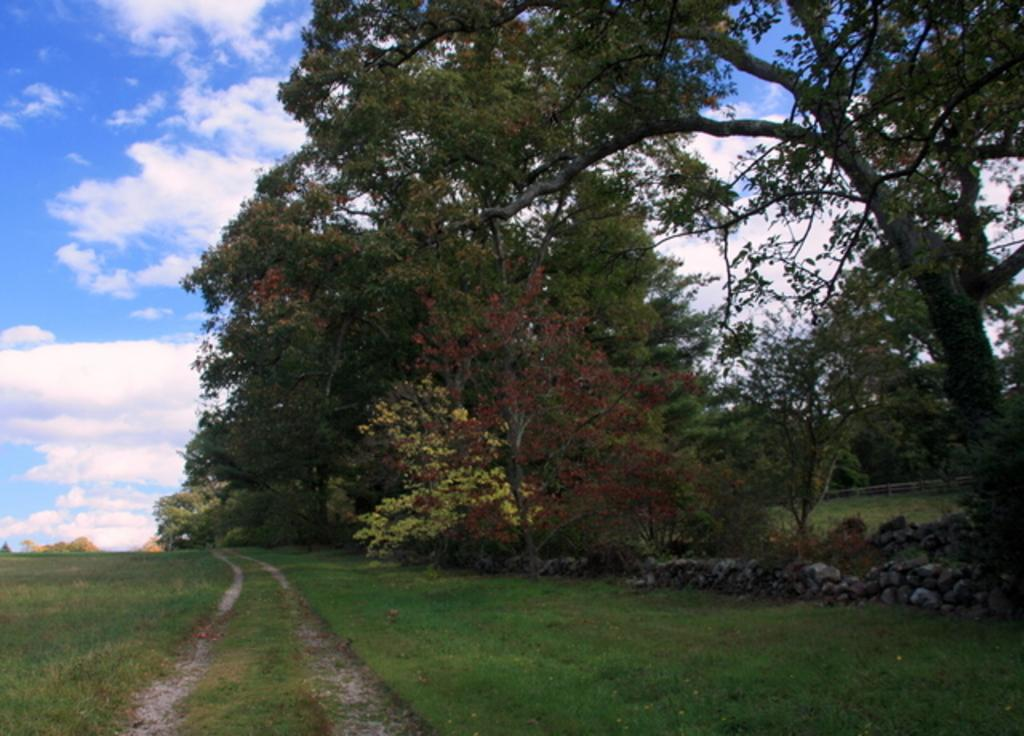What type of vegetation can be seen in the image? There are trees in the image. What color are the trees? The trees are green. What other natural elements can be seen in the image? There is grass in the image. What color is the grass? The grass is green. What else is present in the image besides vegetation? There are rocks in the image. What can be seen in the background of the image? The sky is visible in the background of the image. What colors are present in the sky? The sky is blue and white in color. How does the ant move on the quiet grass in the image? There is no ant present in the image, and the grass is not described as quiet. 